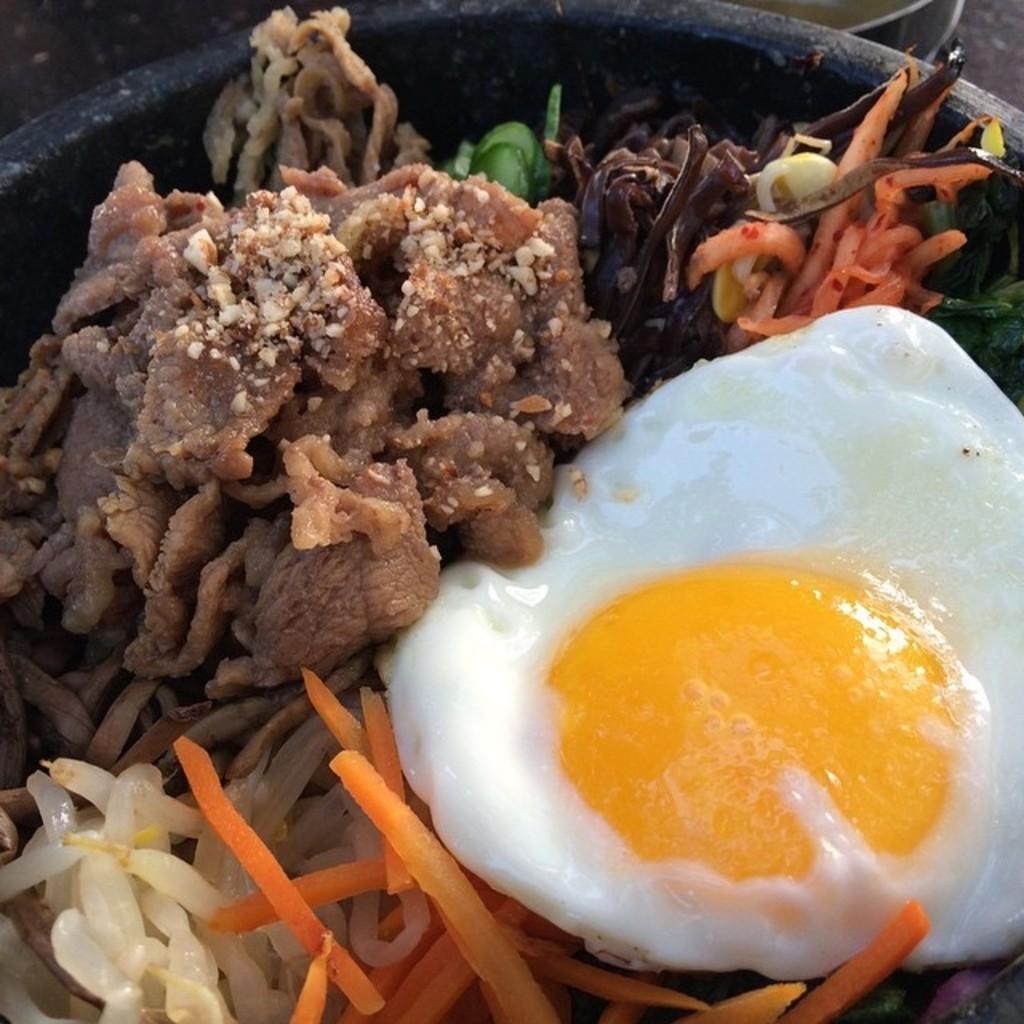Please provide a concise description of this image. There are different food items in the black color bowl. 